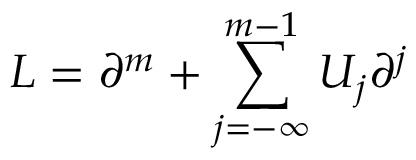<formula> <loc_0><loc_0><loc_500><loc_500>L = \partial ^ { m } + \sum _ { j = - \infty } ^ { m - 1 } U _ { j } \partial ^ { j }</formula> 